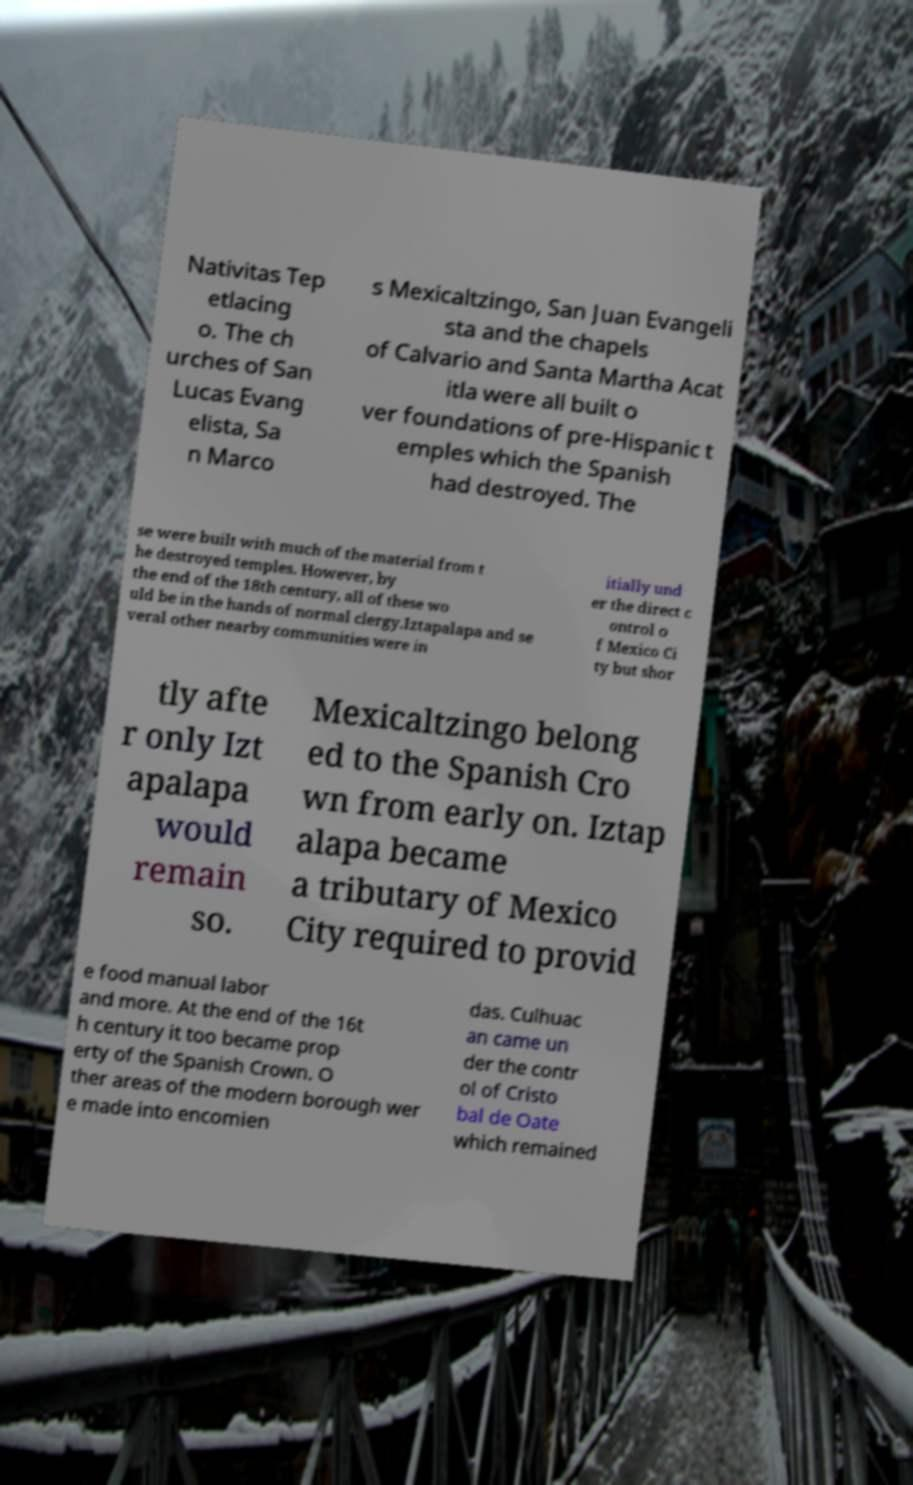Could you extract and type out the text from this image? Nativitas Tep etlacing o. The ch urches of San Lucas Evang elista, Sa n Marco s Mexicaltzingo, San Juan Evangeli sta and the chapels of Calvario and Santa Martha Acat itla were all built o ver foundations of pre-Hispanic t emples which the Spanish had destroyed. The se were built with much of the material from t he destroyed temples. However, by the end of the 18th century, all of these wo uld be in the hands of normal clergy.Iztapalapa and se veral other nearby communities were in itially und er the direct c ontrol o f Mexico Ci ty but shor tly afte r only Izt apalapa would remain so. Mexicaltzingo belong ed to the Spanish Cro wn from early on. Iztap alapa became a tributary of Mexico City required to provid e food manual labor and more. At the end of the 16t h century it too became prop erty of the Spanish Crown. O ther areas of the modern borough wer e made into encomien das. Culhuac an came un der the contr ol of Cristo bal de Oate which remained 